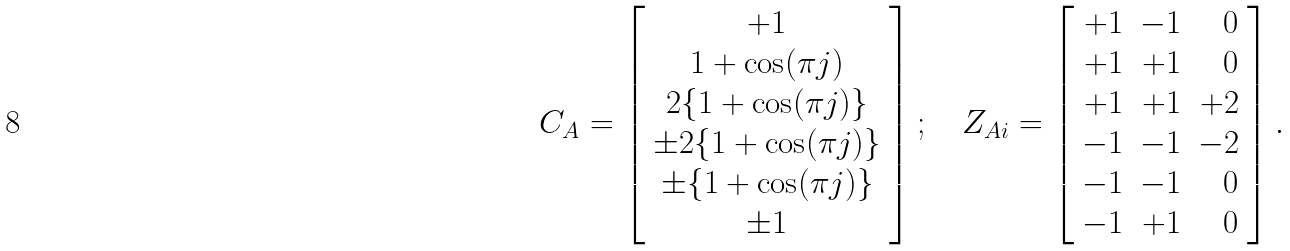<formula> <loc_0><loc_0><loc_500><loc_500>C _ { A } = \left [ \begin{array} { c } + 1 \\ 1 + \cos ( \pi j ) \\ 2 \{ 1 + \cos ( \pi j ) \} \\ \pm 2 \{ 1 + \cos ( \pi j ) \} \\ \pm \{ 1 + \cos ( \pi j ) \} \\ \pm 1 \\ \end{array} \right ] ; \quad Z _ { A i } = \left [ \begin{array} { r r r } + 1 & - 1 & 0 \\ + 1 & + 1 & 0 \\ + 1 & + 1 & + 2 \\ - 1 & - 1 & - 2 \\ - 1 & - 1 & 0 \\ - 1 & + 1 & 0 \\ \end{array} \right ] .</formula> 